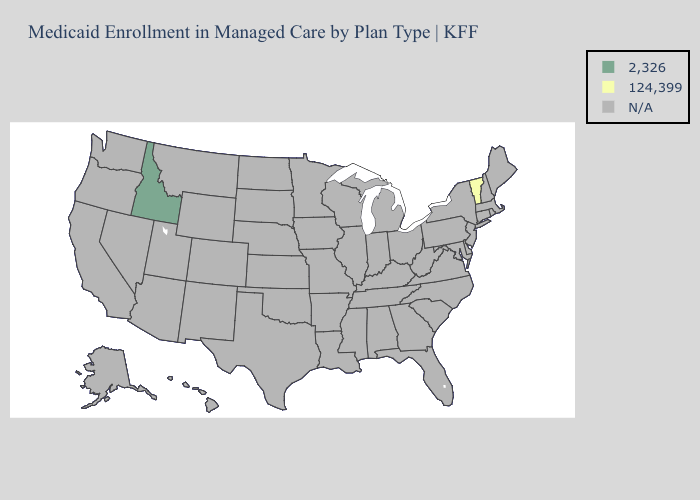What is the value of Colorado?
Short answer required. N/A. Which states have the highest value in the USA?
Short answer required. Idaho. What is the value of Washington?
Write a very short answer. N/A. What is the lowest value in states that border Wyoming?
Be succinct. 2,326. What is the lowest value in states that border Nevada?
Be succinct. 2,326. What is the value of Delaware?
Quick response, please. N/A. Is the legend a continuous bar?
Write a very short answer. No. What is the value of Alabama?
Be succinct. N/A. Does the map have missing data?
Be succinct. Yes. What is the value of New Jersey?
Be succinct. N/A. 